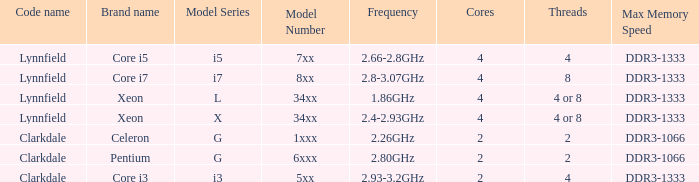What brand is model I7-8xx? Core i7. 